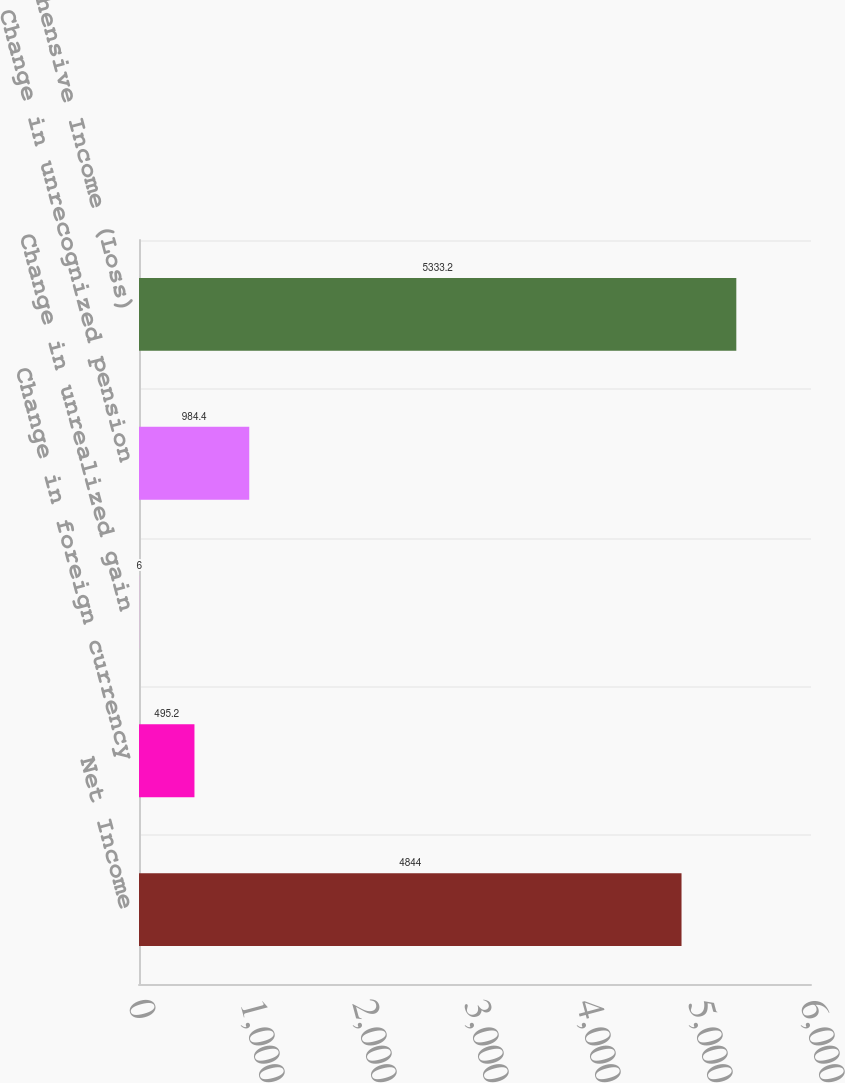<chart> <loc_0><loc_0><loc_500><loc_500><bar_chart><fcel>Net Income<fcel>Change in foreign currency<fcel>Change in unrealized gain<fcel>Change in unrecognized pension<fcel>Comprehensive Income (Loss)<nl><fcel>4844<fcel>495.2<fcel>6<fcel>984.4<fcel>5333.2<nl></chart> 